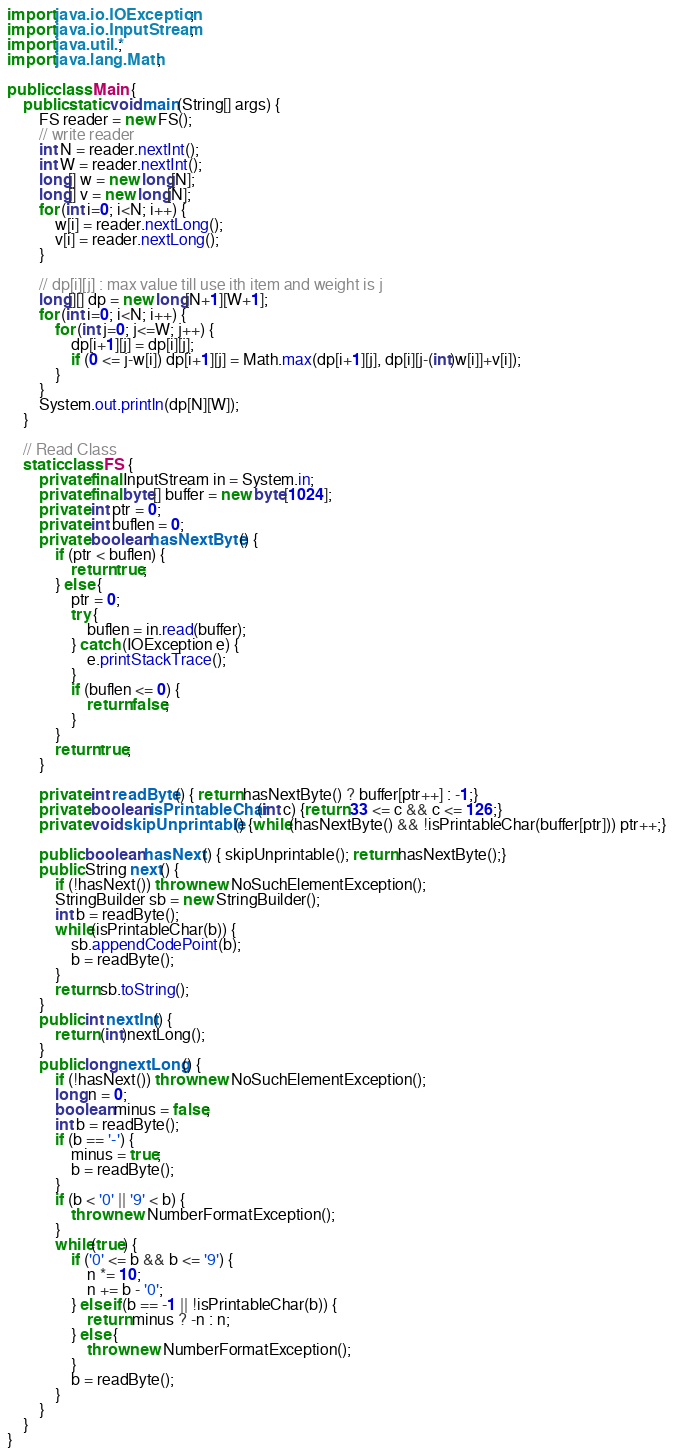Convert code to text. <code><loc_0><loc_0><loc_500><loc_500><_Java_>import java.io.IOException;
import java.io.InputStream;
import java.util.*;
import java.lang.Math;

public class Main {
    public static void main(String[] args) {
        FS reader = new FS();
        // write reader
        int N = reader.nextInt();
        int W = reader.nextInt();
        long[] w = new long[N];
        long[] v = new long[N];
        for (int i=0; i<N; i++) {
            w[i] = reader.nextLong();
            v[i] = reader.nextLong();
        }

        // dp[i][j] : max value till use ith item and weight is j
        long[][] dp = new long[N+1][W+1];
        for (int i=0; i<N; i++) {
            for (int j=0; j<=W; j++) {
                dp[i+1][j] = dp[i][j];
                if (0 <= j-w[i]) dp[i+1][j] = Math.max(dp[i+1][j], dp[i][j-(int)w[i]]+v[i]);
            }
        }
        System.out.println(dp[N][W]);
    }

    // Read Class
    static class FS {
        private final InputStream in = System.in;
        private final byte[] buffer = new byte[1024];
        private int ptr = 0;
        private int buflen = 0;
        private boolean hasNextByte() {
            if (ptr < buflen) {
                return true;
            } else {
                ptr = 0;
                try {
                    buflen = in.read(buffer);
                } catch (IOException e) {
                    e.printStackTrace();
                }
                if (buflen <= 0) {
                    return false;
                }
            }
            return true;
        }
    
        private int readByte() { return hasNextByte() ? buffer[ptr++] : -1;}
        private boolean isPrintableChar(int c) {return 33 <= c && c <= 126;}
        private void skipUnprintable() {while(hasNextByte() && !isPrintableChar(buffer[ptr])) ptr++;}
    
        public boolean hasNext() { skipUnprintable(); return hasNextByte();}
        public String next() {
            if (!hasNext()) throw new NoSuchElementException();
            StringBuilder sb = new StringBuilder();
            int b = readByte();
            while(isPrintableChar(b)) {
                sb.appendCodePoint(b);
                b = readByte();
            }
            return sb.toString();
        }
        public int nextInt() {
            return (int)nextLong();
        }
        public long nextLong() {
            if (!hasNext()) throw new NoSuchElementException();
            long n = 0;
            boolean minus = false;
            int b = readByte();
            if (b == '-') {
                minus = true;
                b = readByte();
            }
            if (b < '0' || '9' < b) {
                throw new NumberFormatException();
            }
            while(true) {
                if ('0' <= b && b <= '9') {
                    n *= 10;
                    n += b - '0';
                } else if(b == -1 || !isPrintableChar(b)) {
                    return minus ? -n : n;
                } else {
                    throw new NumberFormatException();
                }
                b = readByte();
            }
        }
    }
}

</code> 